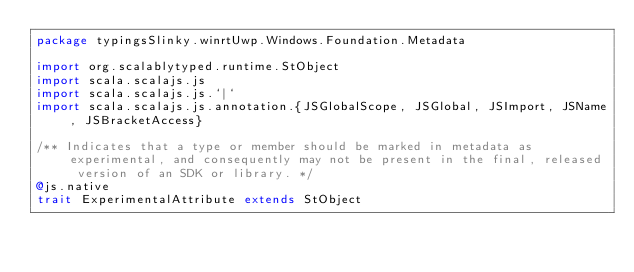<code> <loc_0><loc_0><loc_500><loc_500><_Scala_>package typingsSlinky.winrtUwp.Windows.Foundation.Metadata

import org.scalablytyped.runtime.StObject
import scala.scalajs.js
import scala.scalajs.js.`|`
import scala.scalajs.js.annotation.{JSGlobalScope, JSGlobal, JSImport, JSName, JSBracketAccess}

/** Indicates that a type or member should be marked in metadata as experimental, and consequently may not be present in the final, released version of an SDK or library. */
@js.native
trait ExperimentalAttribute extends StObject
</code> 